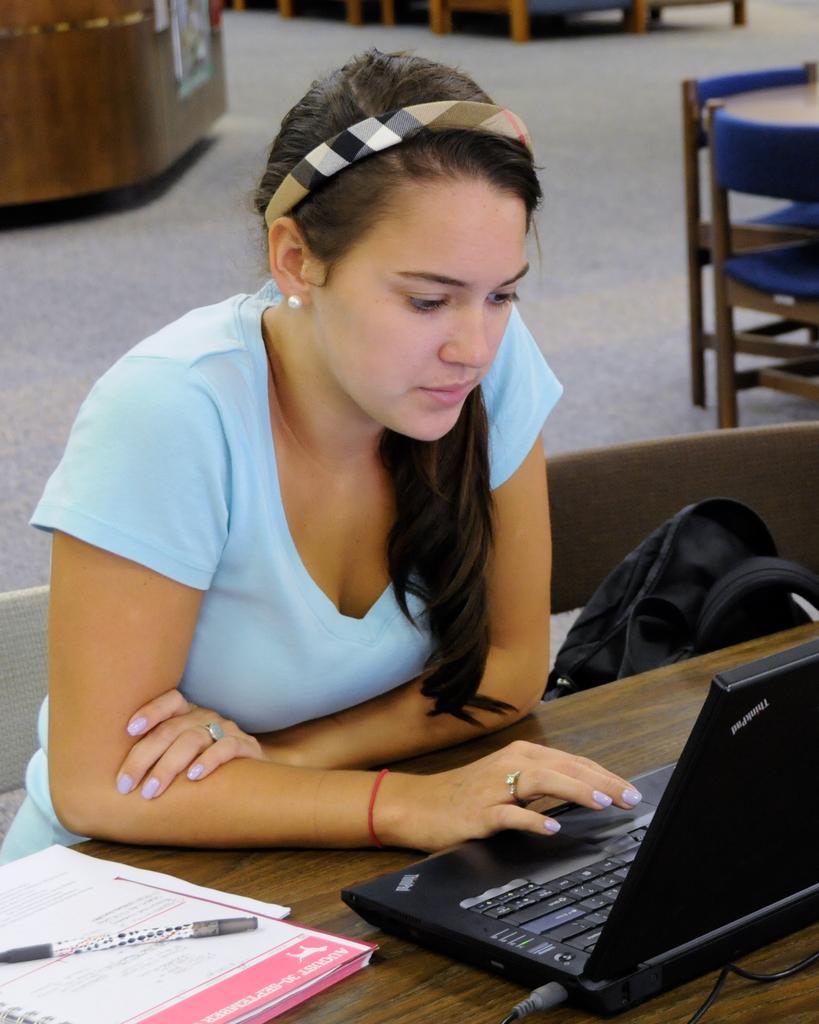How would you summarize this image in a sentence or two? In this image there is a woman who is sitting on chair and working with a laptop which is kept on table. On the table there is book,pen. Beside her there is a bag which is kept on chair. At the background there are chairs and desk 